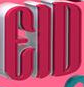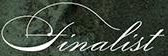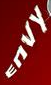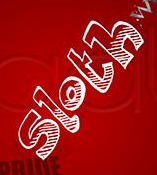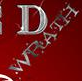Identify the words shown in these images in order, separated by a semicolon. EID; finalist; ENVY; sloth; WRATH 